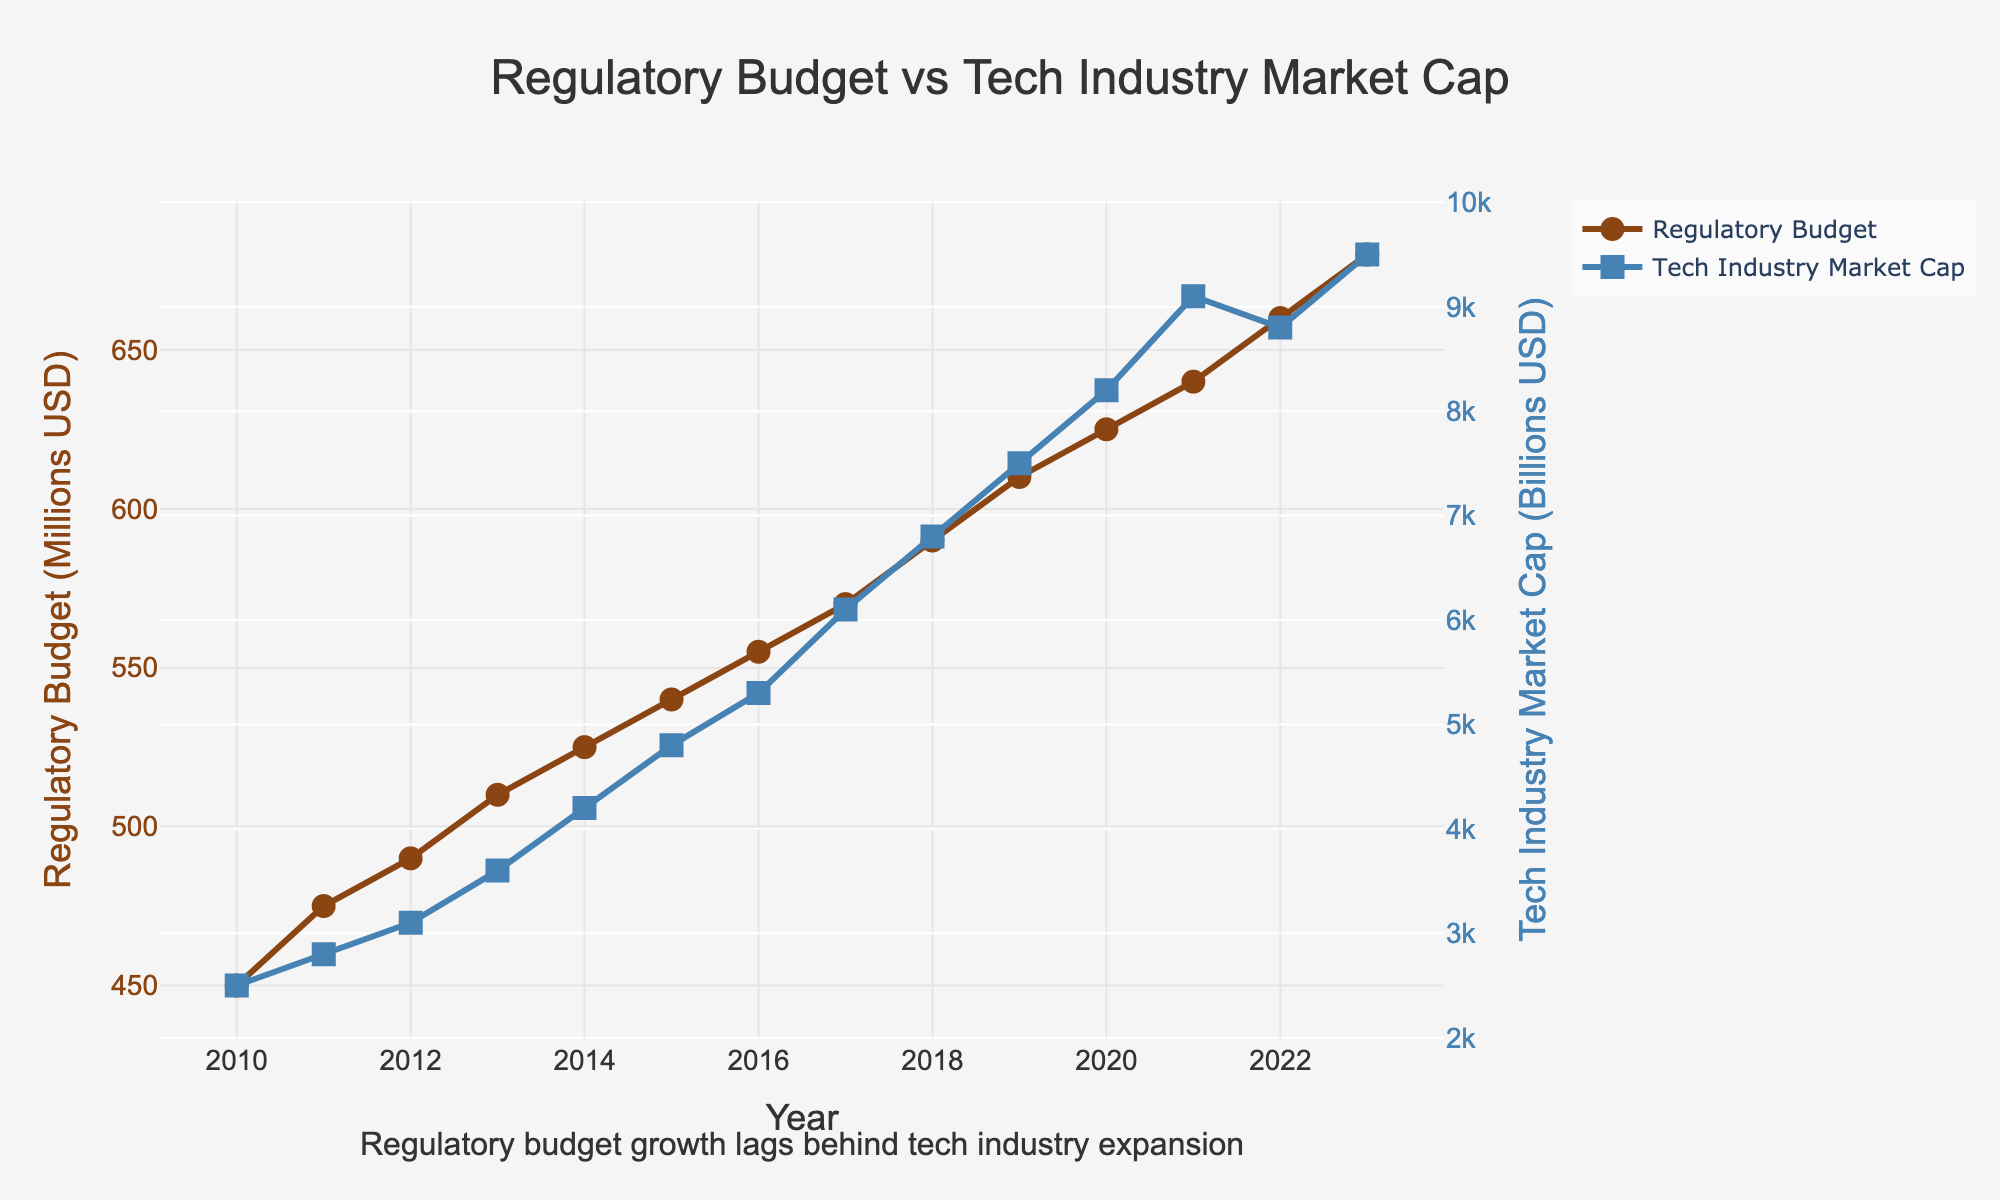What is the difference between the regulatory budget and the tech industry market cap in 2010? Look at the y-values for 2010. The regulatory budget is 450 million USD, and the tech industry market cap is 2500 billion USD. The difference is 2500 - 0.45 (since we need to convert million to billion for comparison) which equals 2499.55 billion USD.
Answer: 2499.55 billion USD Between which years did the regulatory budget experience the highest increase? Calculate the year-on-year increase in the regulatory budget. The highest increase is between 2011 and 2012, where it goes from 475 to 490 million USD (increase of 15 million USD).
Answer: 2011-2012 In which year did the tech industry market cap first exceed 5000 billion USD? Trace the y-values of the 'Tech Industry Market Cap' line and note that it first exceeds 5000 billion USD in 2015 with a market cap of 5300 billion USD.
Answer: 2015 How many times greater is the market cap compared to the regulatory budget in 2023? The regulatory budget in 2023 is 680 million USD, and the tech industry market cap is 9500 billion USD. Convert the regulatory budget to billion (0.68 billion USD). Divide 9500 by 0.68 to get approximately 13969. This means the market cap is 13969 times greater than the budget.
Answer: 13969 times Describe the trend of the regulatory budget and tech industry market cap from 2010 to 2023. Both lines generally trend upwards. The regulatory budget increases relatively steadily from 450 million USD to 680 million USD. The tech industry market cap also increases but at a faster and more variable rate, from 2500 billion USD to 9500 billion USD.
Answer: Upward trend for both By what percentage did the regulatory budget increase from 2010 to 2023? The regulatory budget in 2010 is 450 million USD and in 2023 is 680 million USD. The percentage increase is ((680 - 450) / 450) * 100, which equals approximately 51.1%.
Answer: 51.1% Which year saw the smallest increase in the regulatory budget? Look at the yearly differences in the regulatory budget values. The smallest increase is from 2010 to 2011, where it increased by 25 million USD (from 450 to 475 million USD).
Answer: 2010-2011 What visual attribute differentiates the regulatory budget line from the tech industry market cap line? The regulatory budget line is colored brown and uses circle markers, while the tech industry market cap line is blue and uses square markers.
Answer: Color and marker shape What was the combined market cap of the tech industry over the years 2020 and 2021? Sum the tech industry market cap values for 2020 and 2021. 8200 billion USD (2020) + 9100 billion USD (2021) = 17300 billion USD.
Answer: 17300 billion USD Considering the trends, predict what might happen to the regulatory budget and tech industry market cap in the near future. Both series show an upward trend. Given the data, it seems likely that both will continue increasing. However, the tech industry market cap is likely to increase at a faster rate and by a larger margin than the regulatory budget.
Answer: Likely to continue increasing 